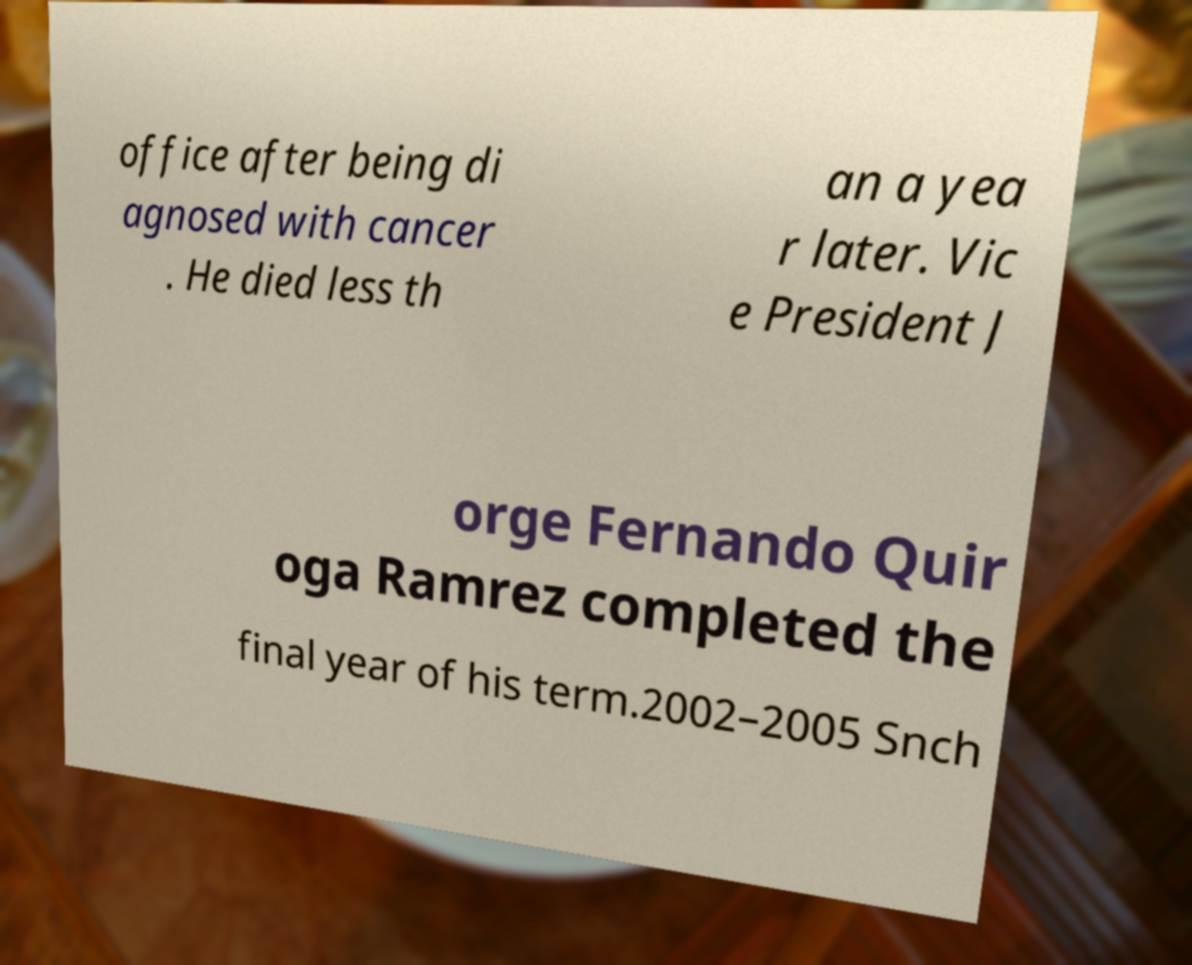Can you read and provide the text displayed in the image?This photo seems to have some interesting text. Can you extract and type it out for me? office after being di agnosed with cancer . He died less th an a yea r later. Vic e President J orge Fernando Quir oga Ramrez completed the final year of his term.2002–2005 Snch 